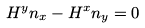Convert formula to latex. <formula><loc_0><loc_0><loc_500><loc_500>H ^ { y } n _ { x } - H ^ { x } n _ { y } = 0</formula> 